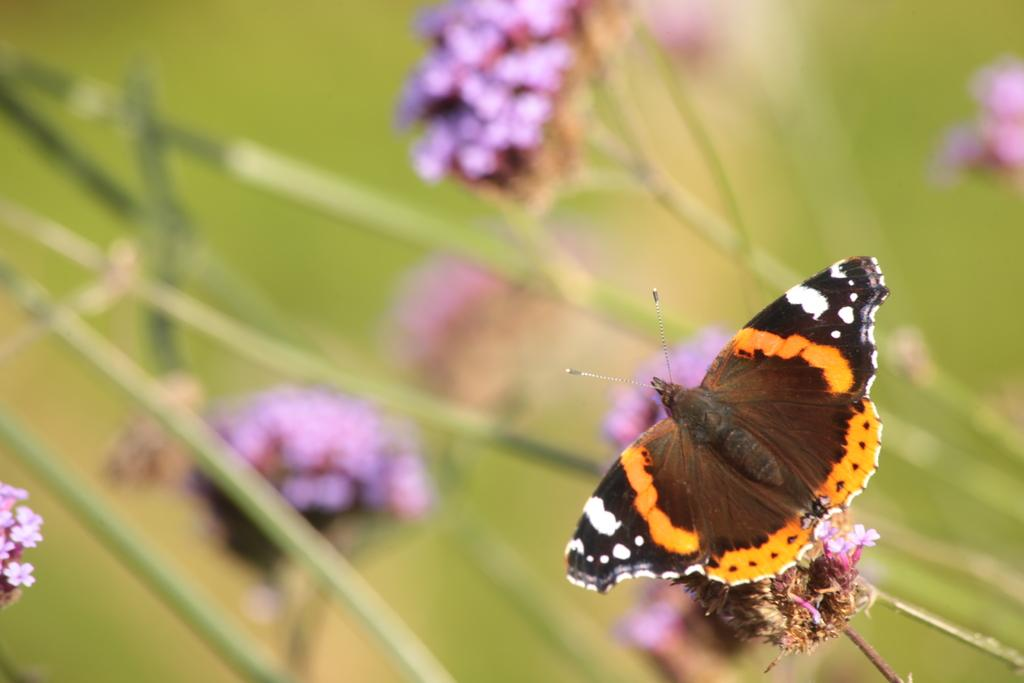What is the main subject of the image? There is a butterfly in the image. Where is the butterfly located in relation to other objects? The butterfly is near flowers. Can you describe the background of the image? The background of the image is blurred. What other objects are present in the image besides the butterfly? There are flowers and stems in the image. What type of wrench is being used by the butterfly in the image? There is no wrench present in the image; it features a butterfly near flowers. How many brothers does the butterfly have in the image? Butterflies do not have brothers, as they are insects and not mammals. 